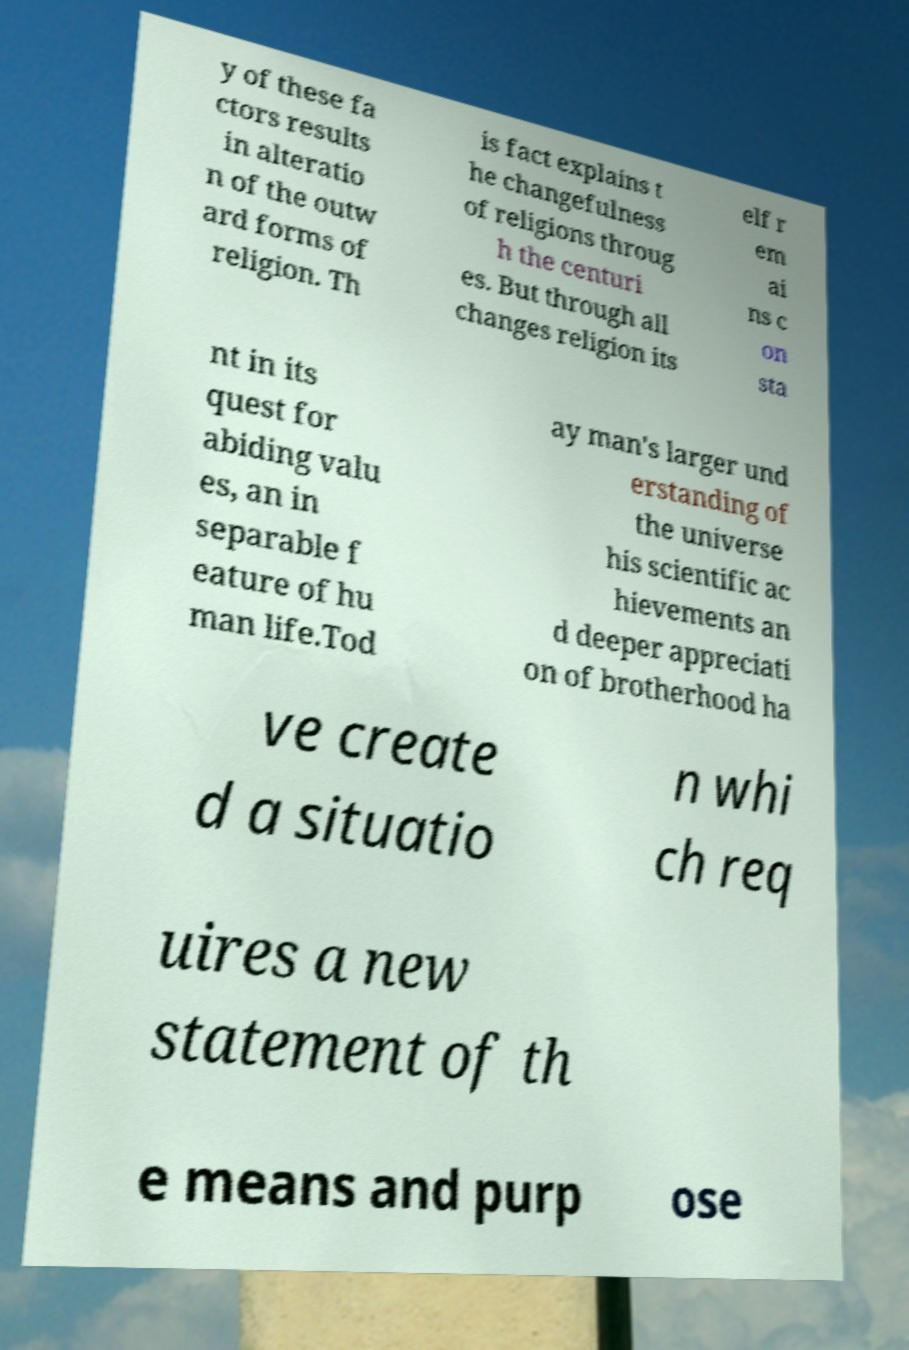I need the written content from this picture converted into text. Can you do that? y of these fa ctors results in alteratio n of the outw ard forms of religion. Th is fact explains t he changefulness of religions throug h the centuri es. But through all changes religion its elf r em ai ns c on sta nt in its quest for abiding valu es, an in separable f eature of hu man life.Tod ay man's larger und erstanding of the universe his scientific ac hievements an d deeper appreciati on of brotherhood ha ve create d a situatio n whi ch req uires a new statement of th e means and purp ose 